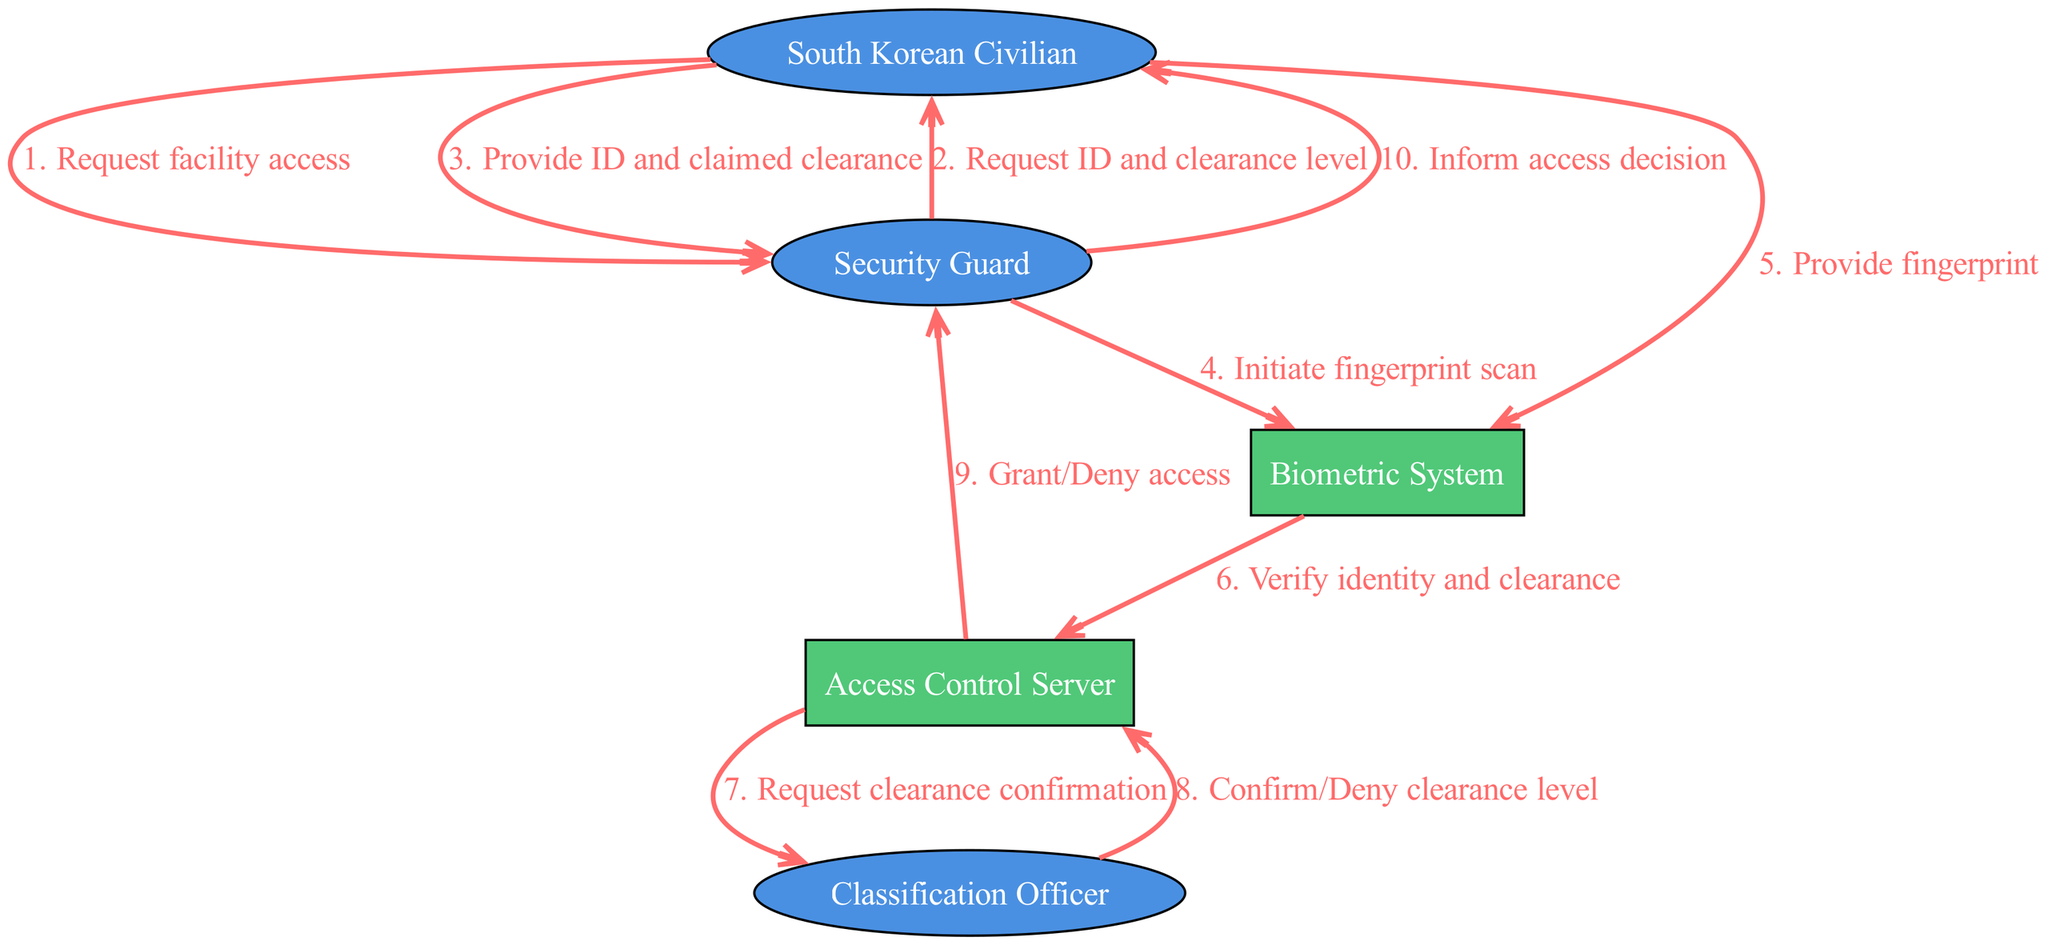What is the first actor in the sequence? The first actor listed in the sequence is "South Korean Civilian", who initiates the process by requesting access to the facility.
Answer: South Korean Civilian How many actors are in the diagram? The diagram contains five actors: South Korean Civilian, Security Guard, Biometric System, Access Control Server, and Classification Officer.
Answer: Five Who requests clearance confirmation? The "Access Control Server" requests clearance confirmation from the "Classification Officer" in the sequence.
Answer: Access Control Server What is the last message in the sequence? The last message in the sequence is from the "Security Guard" to the "South Korean Civilian", informing them of the access decision.
Answer: Inform access decision Which actor confirms or denies the clearance level? The "Classification Officer" is responsible for confirming or denying the clearance level requested by the Access Control Server.
Answer: Classification Officer How many messages are exchanged between the South Korean Civilian and the Security Guard? There are four messages exchanged between the South Korean Civilian and the Security Guard, with repeated interactions for request and response.
Answer: Four What action does the Biometric System perform? The Biometric System performs the action of verifying the identity and clearance by processing the fingerprint data provided.
Answer: Verify identity and clearance What does the Security Guard ask first? The Security Guard initially asks for the "ID and clearance level" from the South Korean Civilian.
Answer: Request ID and clearance level What happens after the Biometric System receives the fingerprint? After receiving the fingerprint, the Biometric System sends the identity verification request to the Access Control Server.
Answer: Verify identity and clearance 